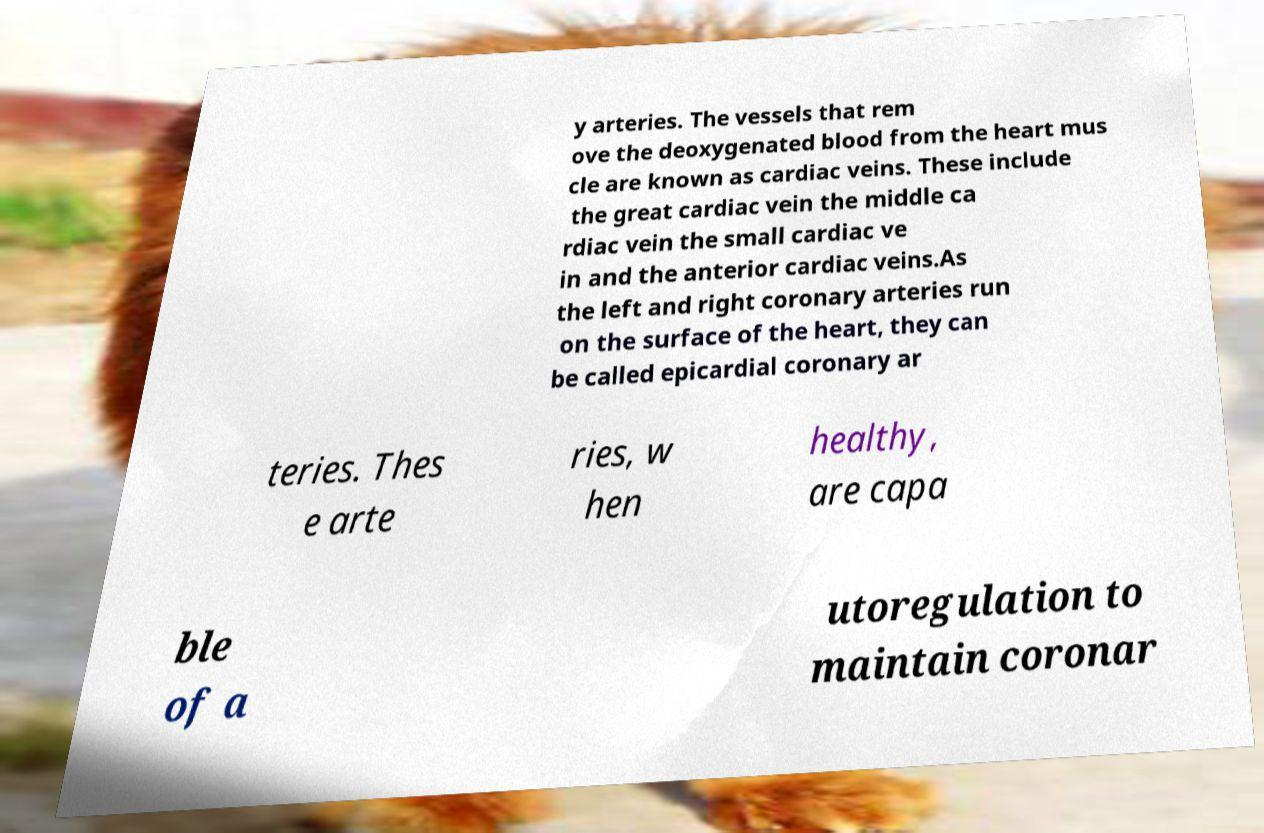Could you assist in decoding the text presented in this image and type it out clearly? y arteries. The vessels that rem ove the deoxygenated blood from the heart mus cle are known as cardiac veins. These include the great cardiac vein the middle ca rdiac vein the small cardiac ve in and the anterior cardiac veins.As the left and right coronary arteries run on the surface of the heart, they can be called epicardial coronary ar teries. Thes e arte ries, w hen healthy, are capa ble of a utoregulation to maintain coronar 